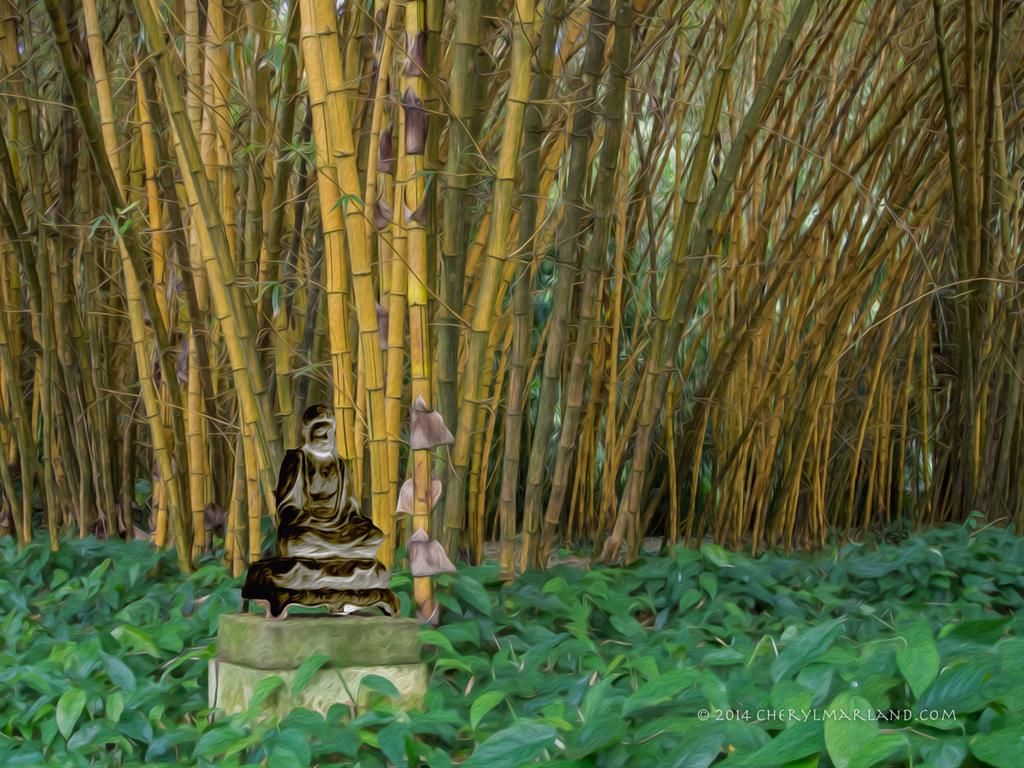What is the main subject of the image? There is a statue in the image. Where is the statue located? The statue is placed on a surface. Can you describe the background of the image? There is a group of trees and plants in the background of the image. Is there any text in the image? Yes, there is some text at the bottom of the image. What type of yarn is used to create the title of the statue in the image? There is no yarn or title present in the image; it features a statue placed on a surface with a background of trees and plants, and some text at the bottom. 